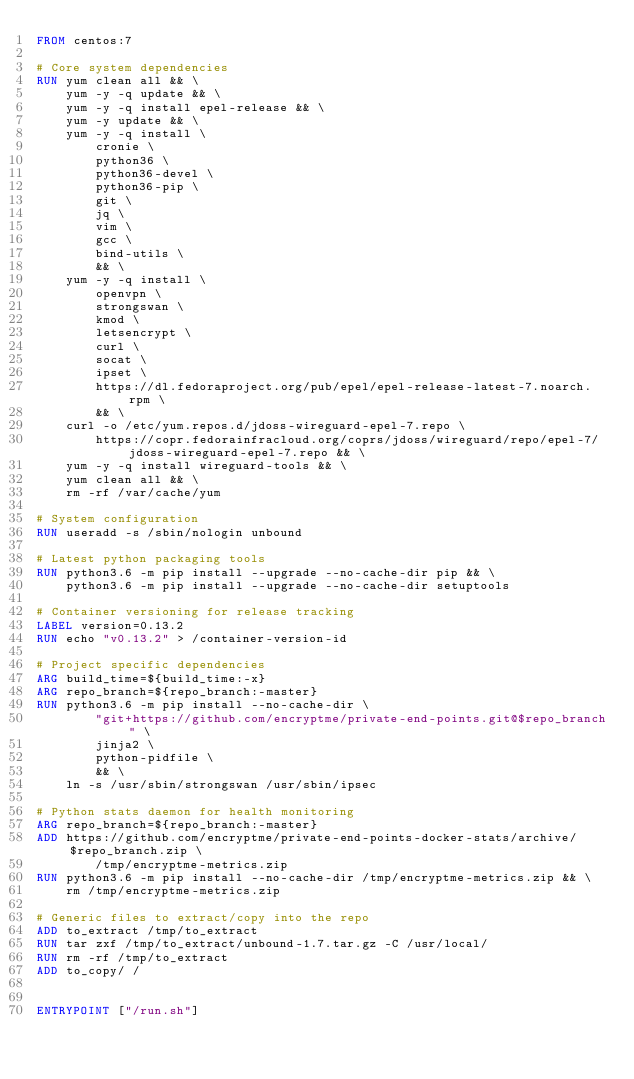Convert code to text. <code><loc_0><loc_0><loc_500><loc_500><_Dockerfile_>FROM centos:7

# Core system dependencies
RUN yum clean all && \
    yum -y -q update && \
    yum -y -q install epel-release && \
    yum -y update && \
    yum -y -q install \
        cronie \
        python36 \
        python36-devel \
        python36-pip \
        git \
        jq \
        vim \
        gcc \
        bind-utils \
        && \
    yum -y -q install \
        openvpn \
        strongswan \
        kmod \
        letsencrypt \
        curl \
        socat \
        ipset \
        https://dl.fedoraproject.org/pub/epel/epel-release-latest-7.noarch.rpm \
        && \
    curl -o /etc/yum.repos.d/jdoss-wireguard-epel-7.repo \
        https://copr.fedorainfracloud.org/coprs/jdoss/wireguard/repo/epel-7/jdoss-wireguard-epel-7.repo && \
    yum -y -q install wireguard-tools && \
    yum clean all && \
    rm -rf /var/cache/yum

# System configuration
RUN useradd -s /sbin/nologin unbound

# Latest python packaging tools
RUN python3.6 -m pip install --upgrade --no-cache-dir pip && \
    python3.6 -m pip install --upgrade --no-cache-dir setuptools

# Container versioning for release tracking
LABEL version=0.13.2
RUN echo "v0.13.2" > /container-version-id

# Project specific dependencies
ARG build_time=${build_time:-x}
ARG repo_branch=${repo_branch:-master}
RUN python3.6 -m pip install --no-cache-dir \
        "git+https://github.com/encryptme/private-end-points.git@$repo_branch" \
        jinja2 \
        python-pidfile \
        && \
    ln -s /usr/sbin/strongswan /usr/sbin/ipsec

# Python stats daemon for health monitoring
ARG repo_branch=${repo_branch:-master}
ADD https://github.com/encryptme/private-end-points-docker-stats/archive/$repo_branch.zip \
        /tmp/encryptme-metrics.zip
RUN python3.6 -m pip install --no-cache-dir /tmp/encryptme-metrics.zip && \
    rm /tmp/encryptme-metrics.zip

# Generic files to extract/copy into the repo
ADD to_extract /tmp/to_extract
RUN tar zxf /tmp/to_extract/unbound-1.7.tar.gz -C /usr/local/
RUN rm -rf /tmp/to_extract
ADD to_copy/ /


ENTRYPOINT ["/run.sh"]
</code> 